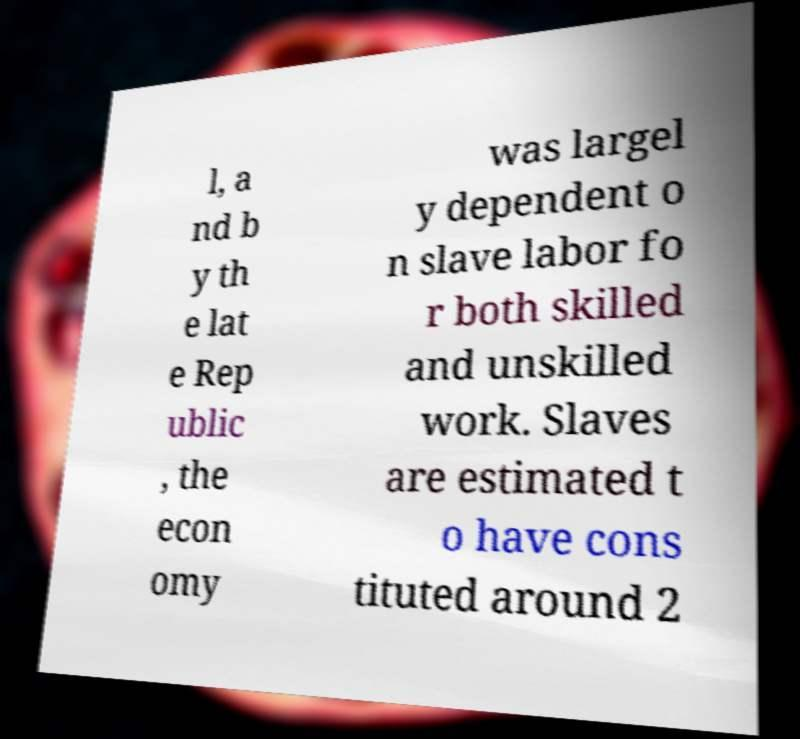Can you read and provide the text displayed in the image?This photo seems to have some interesting text. Can you extract and type it out for me? l, a nd b y th e lat e Rep ublic , the econ omy was largel y dependent o n slave labor fo r both skilled and unskilled work. Slaves are estimated t o have cons tituted around 2 